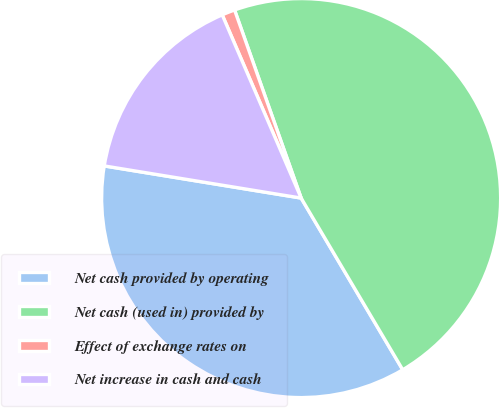Convert chart. <chart><loc_0><loc_0><loc_500><loc_500><pie_chart><fcel>Net cash provided by operating<fcel>Net cash (used in) provided by<fcel>Effect of exchange rates on<fcel>Net increase in cash and cash<nl><fcel>36.08%<fcel>46.91%<fcel>1.06%<fcel>15.95%<nl></chart> 